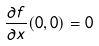Convert formula to latex. <formula><loc_0><loc_0><loc_500><loc_500>\frac { \partial f } { \partial x } ( 0 , 0 ) = 0</formula> 